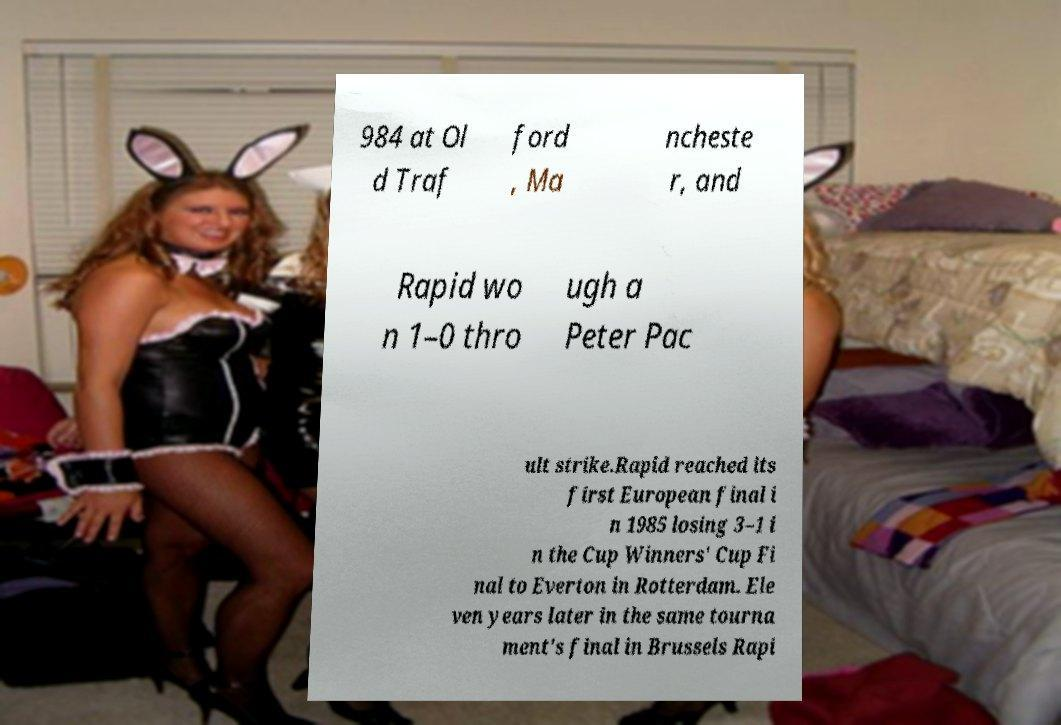Can you accurately transcribe the text from the provided image for me? 984 at Ol d Traf ford , Ma ncheste r, and Rapid wo n 1–0 thro ugh a Peter Pac ult strike.Rapid reached its first European final i n 1985 losing 3–1 i n the Cup Winners' Cup Fi nal to Everton in Rotterdam. Ele ven years later in the same tourna ment's final in Brussels Rapi 